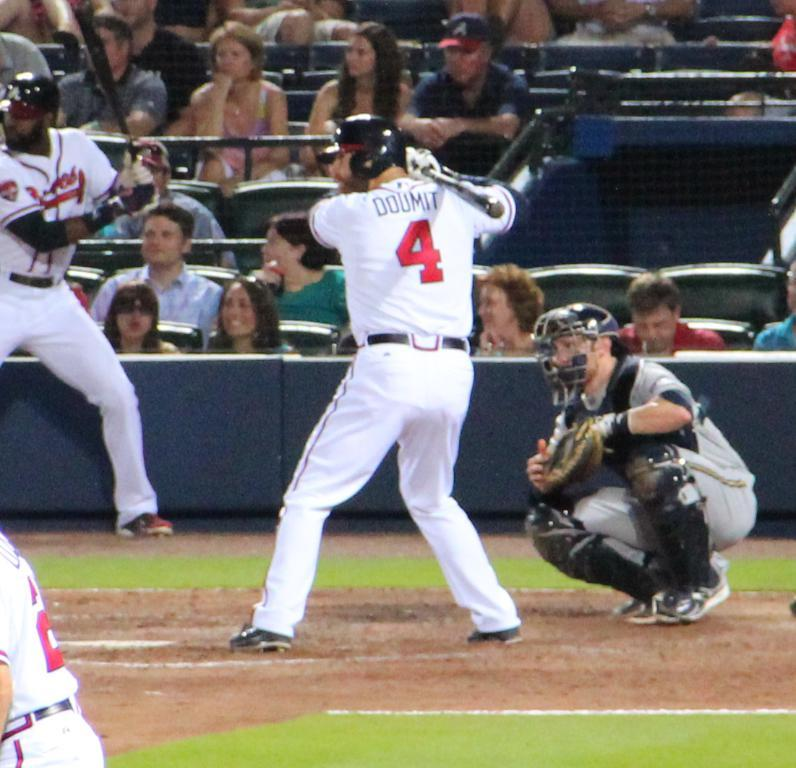Provide a one-sentence caption for the provided image. a person wearing the number 4 on their baseball jersey. 